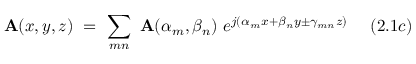<formula> <loc_0><loc_0><loc_500><loc_500>A ( x , y , z ) = \sum _ { m n } A ( \alpha _ { m } , \beta _ { n } ) e ^ { j ( \alpha _ { m } x + \beta _ { n } y \pm \gamma _ { m n } z ) } ( 2 . 1 c )</formula> 